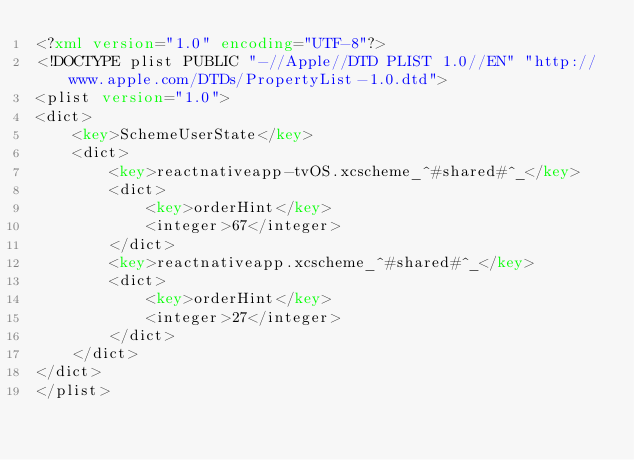Convert code to text. <code><loc_0><loc_0><loc_500><loc_500><_XML_><?xml version="1.0" encoding="UTF-8"?>
<!DOCTYPE plist PUBLIC "-//Apple//DTD PLIST 1.0//EN" "http://www.apple.com/DTDs/PropertyList-1.0.dtd">
<plist version="1.0">
<dict>
	<key>SchemeUserState</key>
	<dict>
		<key>reactnativeapp-tvOS.xcscheme_^#shared#^_</key>
		<dict>
			<key>orderHint</key>
			<integer>67</integer>
		</dict>
		<key>reactnativeapp.xcscheme_^#shared#^_</key>
		<dict>
			<key>orderHint</key>
			<integer>27</integer>
		</dict>
	</dict>
</dict>
</plist>
</code> 